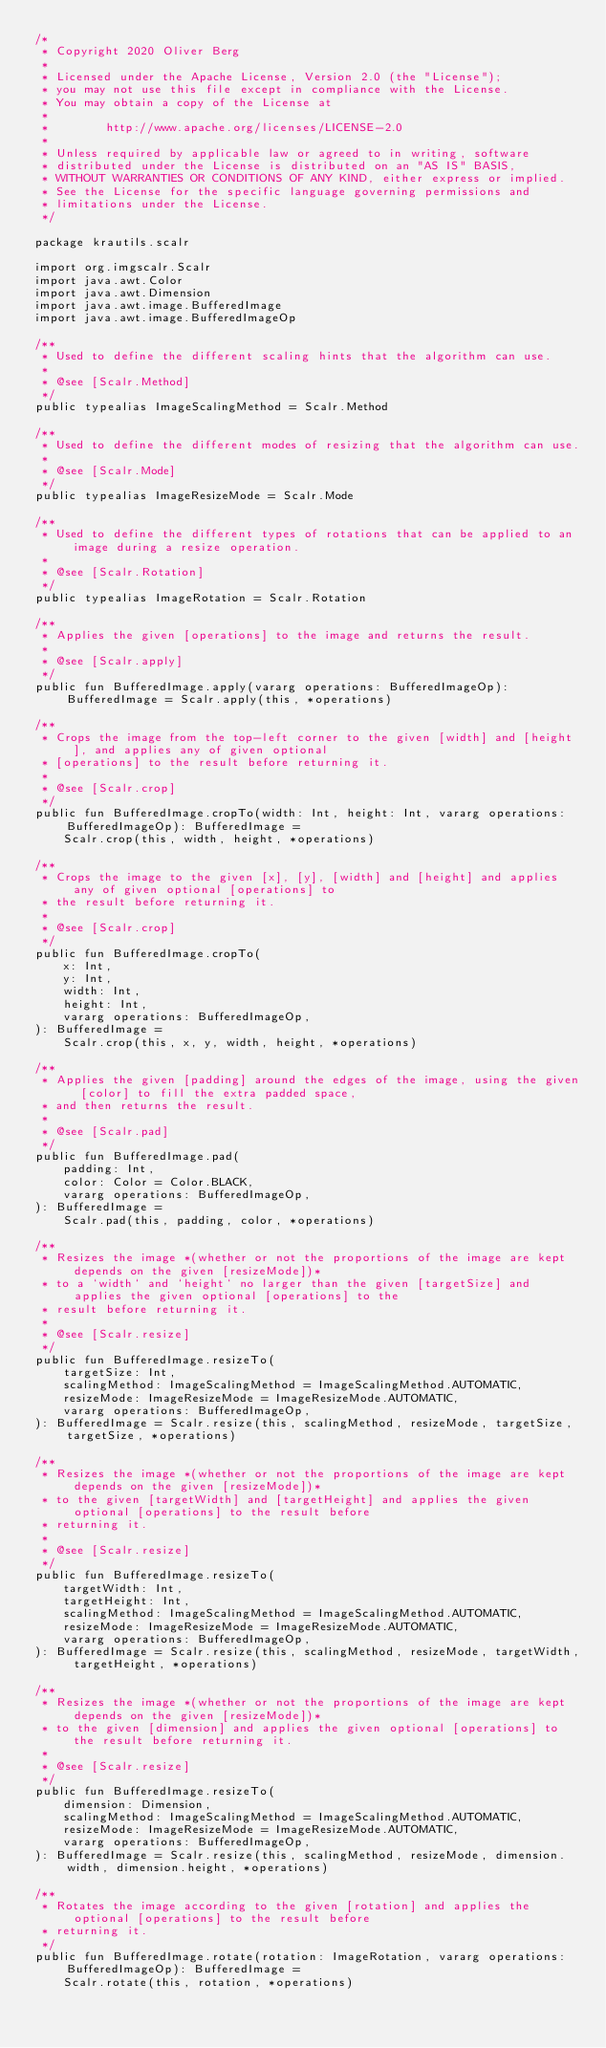<code> <loc_0><loc_0><loc_500><loc_500><_Kotlin_>/*
 * Copyright 2020 Oliver Berg
 *
 * Licensed under the Apache License, Version 2.0 (the "License");
 * you may not use this file except in compliance with the License.
 * You may obtain a copy of the License at
 *
 *        http://www.apache.org/licenses/LICENSE-2.0
 *
 * Unless required by applicable law or agreed to in writing, software
 * distributed under the License is distributed on an "AS IS" BASIS,
 * WITHOUT WARRANTIES OR CONDITIONS OF ANY KIND, either express or implied.
 * See the License for the specific language governing permissions and
 * limitations under the License.
 */

package krautils.scalr

import org.imgscalr.Scalr
import java.awt.Color
import java.awt.Dimension
import java.awt.image.BufferedImage
import java.awt.image.BufferedImageOp

/**
 * Used to define the different scaling hints that the algorithm can use.
 *
 * @see [Scalr.Method]
 */
public typealias ImageScalingMethod = Scalr.Method

/**
 * Used to define the different modes of resizing that the algorithm can use.
 *
 * @see [Scalr.Mode]
 */
public typealias ImageResizeMode = Scalr.Mode

/**
 * Used to define the different types of rotations that can be applied to an image during a resize operation.
 *
 * @see [Scalr.Rotation]
 */
public typealias ImageRotation = Scalr.Rotation

/**
 * Applies the given [operations] to the image and returns the result.
 *
 * @see [Scalr.apply]
 */
public fun BufferedImage.apply(vararg operations: BufferedImageOp): BufferedImage = Scalr.apply(this, *operations)

/**
 * Crops the image from the top-left corner to the given [width] and [height], and applies any of given optional
 * [operations] to the result before returning it.
 *
 * @see [Scalr.crop]
 */
public fun BufferedImage.cropTo(width: Int, height: Int, vararg operations: BufferedImageOp): BufferedImage =
    Scalr.crop(this, width, height, *operations)

/**
 * Crops the image to the given [x], [y], [width] and [height] and applies any of given optional [operations] to
 * the result before returning it.
 *
 * @see [Scalr.crop]
 */
public fun BufferedImage.cropTo(
    x: Int,
    y: Int,
    width: Int,
    height: Int,
    vararg operations: BufferedImageOp,
): BufferedImage =
    Scalr.crop(this, x, y, width, height, *operations)

/**
 * Applies the given [padding] around the edges of the image, using the given [color] to fill the extra padded space,
 * and then returns the result.
 *
 * @see [Scalr.pad]
 */
public fun BufferedImage.pad(
    padding: Int,
    color: Color = Color.BLACK,
    vararg operations: BufferedImageOp,
): BufferedImage =
    Scalr.pad(this, padding, color, *operations)

/**
 * Resizes the image *(whether or not the proportions of the image are kept depends on the given [resizeMode])*
 * to a `width` and `height` no larger than the given [targetSize] and applies the given optional [operations] to the
 * result before returning it.
 *
 * @see [Scalr.resize]
 */
public fun BufferedImage.resizeTo(
    targetSize: Int,
    scalingMethod: ImageScalingMethod = ImageScalingMethod.AUTOMATIC,
    resizeMode: ImageResizeMode = ImageResizeMode.AUTOMATIC,
    vararg operations: BufferedImageOp,
): BufferedImage = Scalr.resize(this, scalingMethod, resizeMode, targetSize, targetSize, *operations)

/**
 * Resizes the image *(whether or not the proportions of the image are kept depends on the given [resizeMode])*
 * to the given [targetWidth] and [targetHeight] and applies the given optional [operations] to the result before
 * returning it.
 *
 * @see [Scalr.resize]
 */
public fun BufferedImage.resizeTo(
    targetWidth: Int,
    targetHeight: Int,
    scalingMethod: ImageScalingMethod = ImageScalingMethod.AUTOMATIC,
    resizeMode: ImageResizeMode = ImageResizeMode.AUTOMATIC,
    vararg operations: BufferedImageOp,
): BufferedImage = Scalr.resize(this, scalingMethod, resizeMode, targetWidth, targetHeight, *operations)

/**
 * Resizes the image *(whether or not the proportions of the image are kept depends on the given [resizeMode])*
 * to the given [dimension] and applies the given optional [operations] to the result before returning it.
 *
 * @see [Scalr.resize]
 */
public fun BufferedImage.resizeTo(
    dimension: Dimension,
    scalingMethod: ImageScalingMethod = ImageScalingMethod.AUTOMATIC,
    resizeMode: ImageResizeMode = ImageResizeMode.AUTOMATIC,
    vararg operations: BufferedImageOp,
): BufferedImage = Scalr.resize(this, scalingMethod, resizeMode, dimension.width, dimension.height, *operations)

/**
 * Rotates the image according to the given [rotation] and applies the optional [operations] to the result before
 * returning it.
 */
public fun BufferedImage.rotate(rotation: ImageRotation, vararg operations: BufferedImageOp): BufferedImage =
    Scalr.rotate(this, rotation, *operations)</code> 